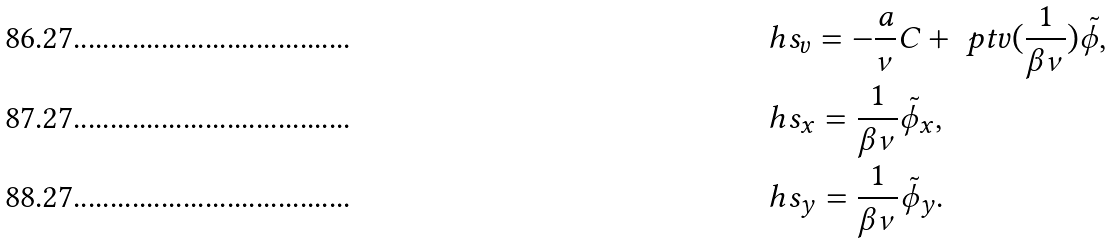Convert formula to latex. <formula><loc_0><loc_0><loc_500><loc_500>& \ h s _ { v } = - \frac { a } { \nu } C + \ p t v ( \frac { 1 } { \beta \nu } ) \tilde { \phi } , \\ & \ h s _ { x } = \frac { 1 } { \beta \nu } \tilde { \phi } _ { x } , \\ & \ h s _ { y } = \frac { 1 } { \beta \nu } \tilde { \phi } _ { y } .</formula> 